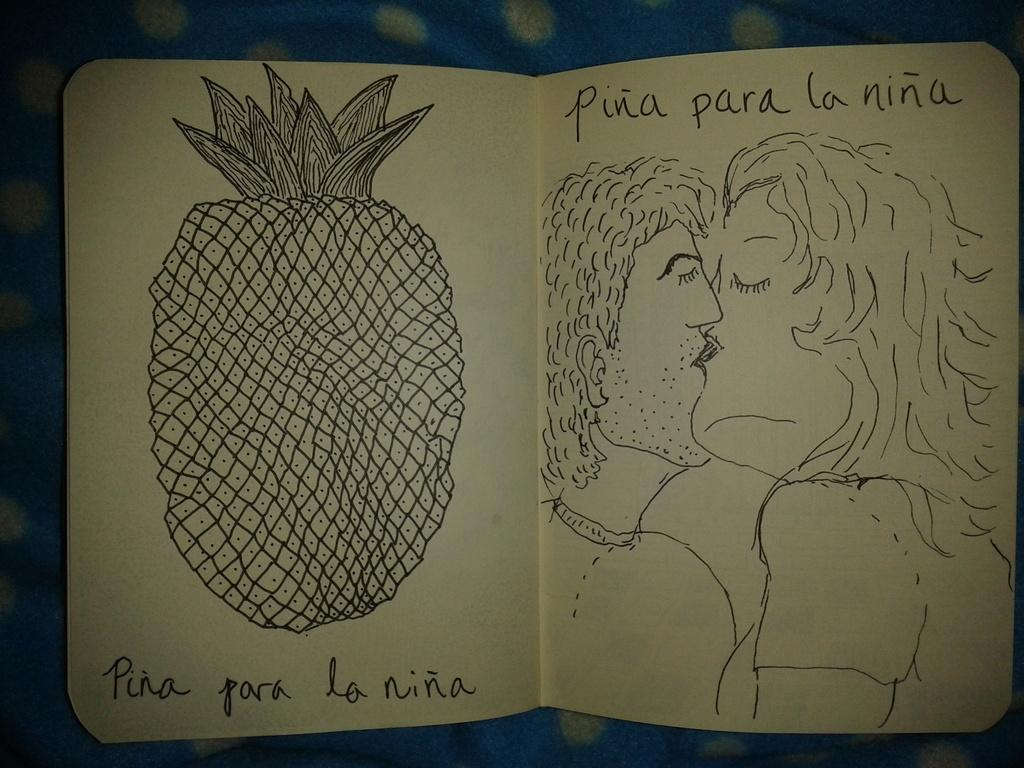What can be seen on the papers in the image? There are drawings on the papers, and something is written on them. Can you describe the content of the drawings or writing? Unfortunately, the specific content of the drawings or writing cannot be determined from the image. What is visible in the background of the image? There is a cloth in the background of the image. What type of drug is visible in the image? There is no drug present in the image. Can you tell me how many mittens are shown in the image? There are no mittens present in the image. 